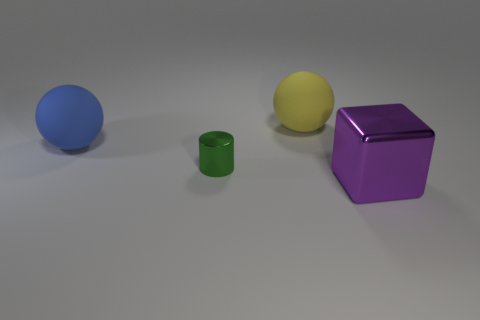Do the green cylinder and the purple cube have the same size?
Your answer should be compact. No. Are there any cyan rubber blocks?
Your answer should be very brief. No. Are there any small cylinders that have the same material as the large yellow sphere?
Your answer should be compact. No. There is a block that is the same size as the blue ball; what is its material?
Offer a very short reply. Metal. What number of big blue rubber objects have the same shape as the yellow rubber thing?
Ensure brevity in your answer.  1. The green cylinder that is made of the same material as the big purple block is what size?
Offer a very short reply. Small. There is a large thing that is in front of the yellow rubber object and right of the blue rubber object; what is its material?
Keep it short and to the point. Metal. How many other purple cubes have the same size as the shiny cube?
Provide a succinct answer. 0. How many objects are big objects in front of the large blue rubber thing or things in front of the big yellow rubber ball?
Give a very brief answer. 3. Is the shape of the green shiny object the same as the metallic thing that is to the right of the tiny green cylinder?
Give a very brief answer. No. 